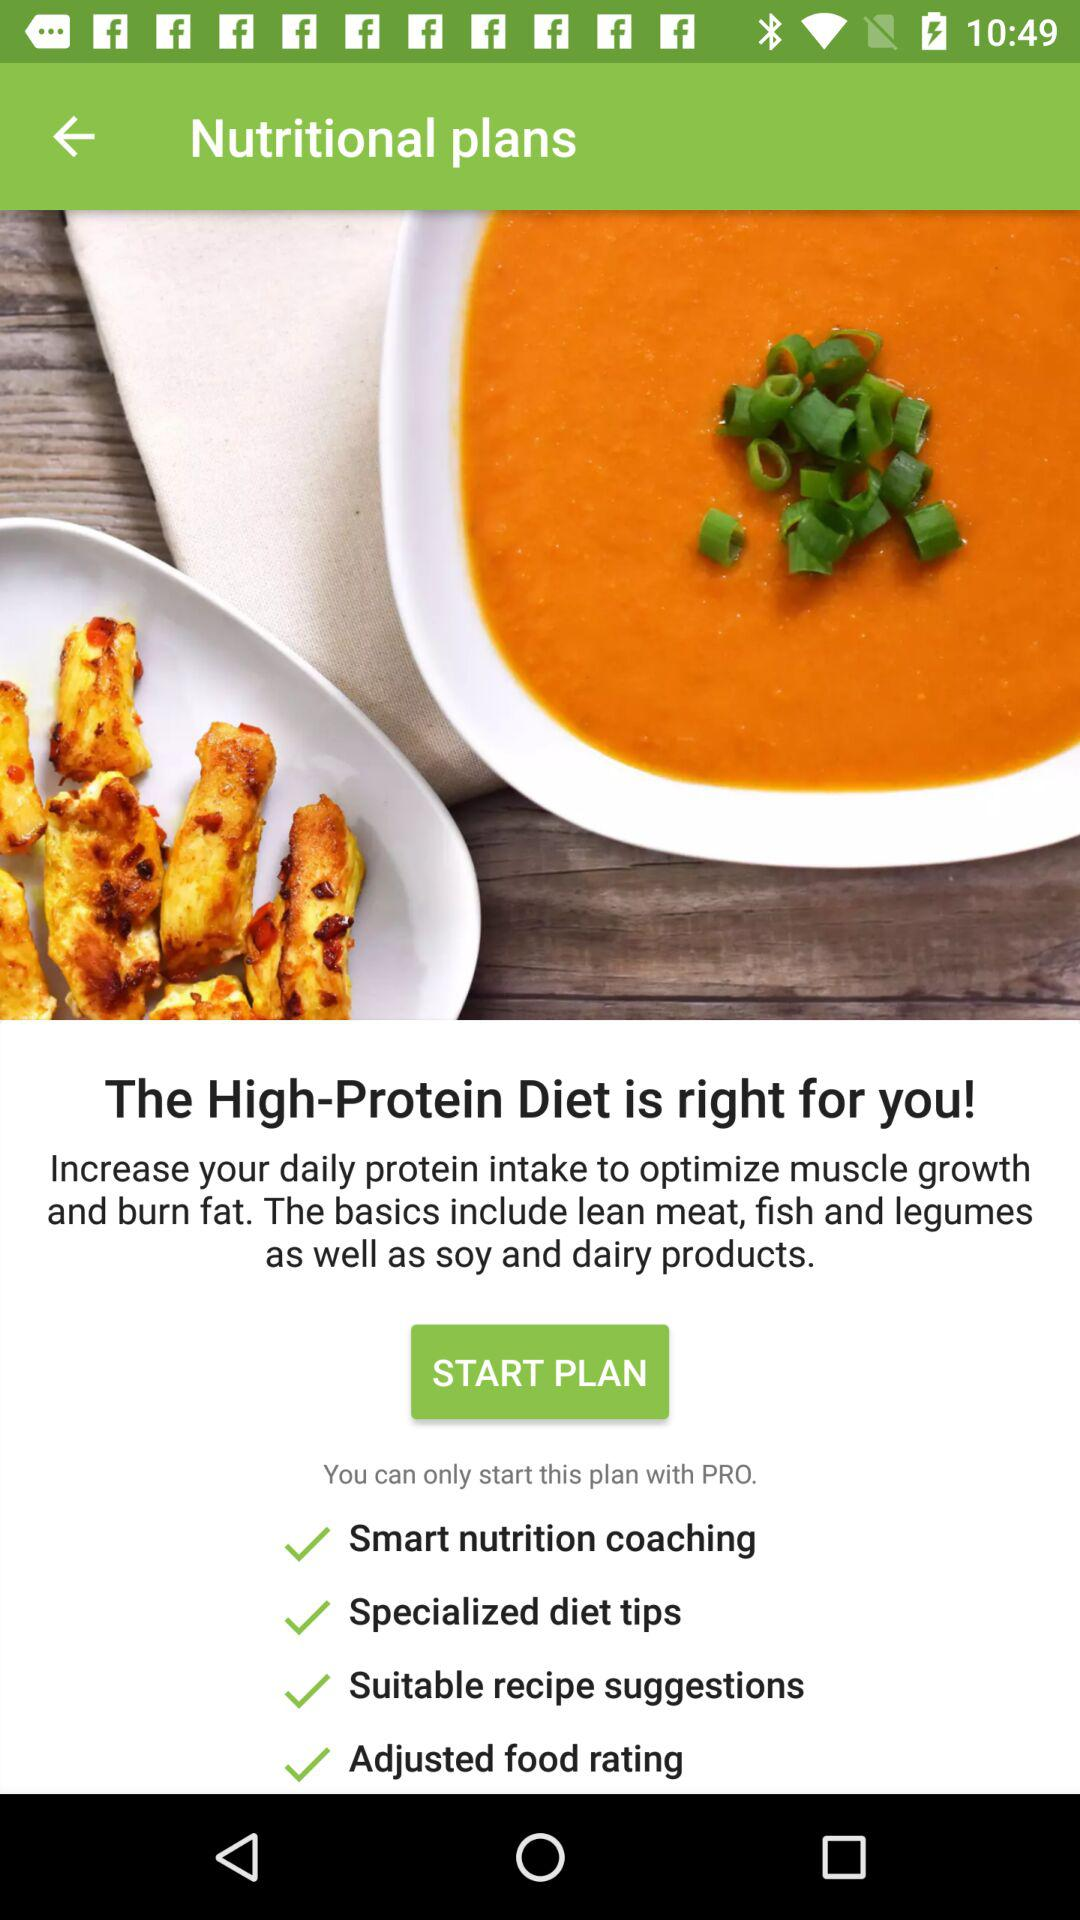How many options are there for cooking your own meals?
Answer the question using a single word or phrase. 3 